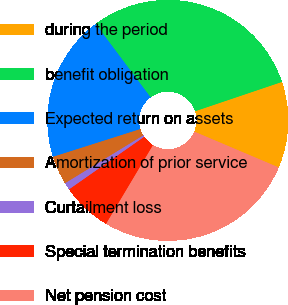Convert chart to OTSL. <chart><loc_0><loc_0><loc_500><loc_500><pie_chart><fcel>during the period<fcel>benefit obligation<fcel>Expected return on assets<fcel>Amortization of prior service<fcel>Curtailment loss<fcel>Special termination benefits<fcel>Net pension cost<nl><fcel>11.57%<fcel>30.05%<fcel>19.67%<fcel>3.85%<fcel>0.97%<fcel>6.73%<fcel>27.17%<nl></chart> 